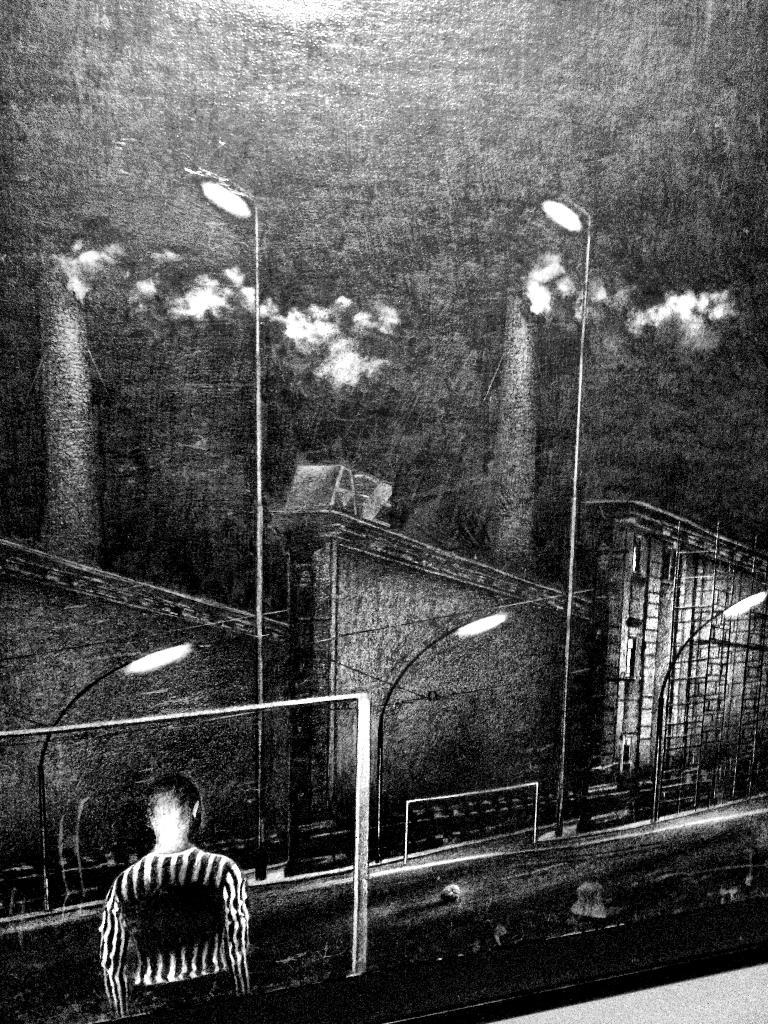What type of artwork is shown in the image? The image appears to be a painting. What structures can be seen in the painting? There are buildings depicted in the painting. What type of lighting is present in the painting? There are pole lights in the painting. Is there any representation of a person in the painting? Yes, there is a picture of a human in the painting. What color is the note left on the sofa in the painting? There is no sofa or note present in the painting; it only features buildings, pole lights, and a human figure. 